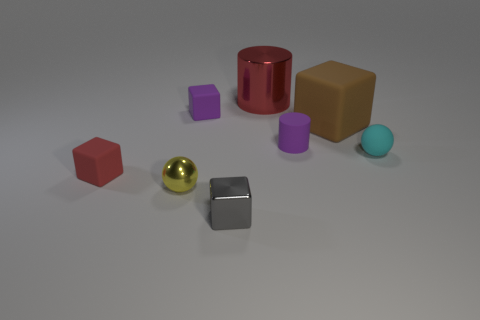The cube that is behind the cyan rubber thing and to the left of the shiny cube is what color?
Make the answer very short. Purple. Are there more small yellow matte cylinders than small metal cubes?
Offer a very short reply. No. What number of objects are tiny purple objects or tiny spheres right of the brown rubber object?
Ensure brevity in your answer.  3. Do the brown cube and the cyan object have the same size?
Your response must be concise. No. There is a small metal cube; are there any cyan rubber balls to the right of it?
Your answer should be very brief. Yes. There is a object that is to the left of the brown cube and on the right side of the red shiny cylinder; how big is it?
Provide a succinct answer. Small. How many things are either cyan rubber balls or big cyan objects?
Offer a very short reply. 1. Is the size of the yellow thing the same as the cylinder behind the small purple cube?
Offer a very short reply. No. There is a purple cylinder that is on the right side of the small matte cube in front of the tiny ball to the right of the tiny gray metal block; what size is it?
Your response must be concise. Small. Are there any metallic blocks?
Ensure brevity in your answer.  Yes. 